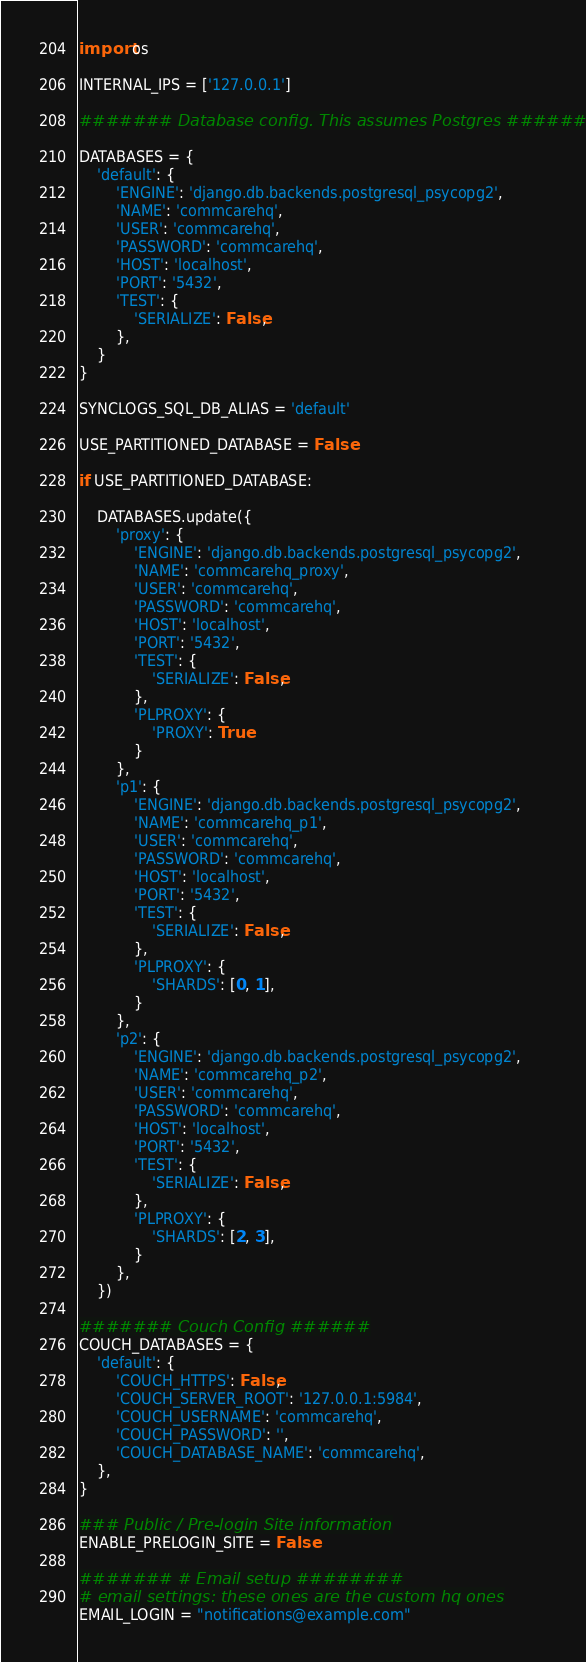Convert code to text. <code><loc_0><loc_0><loc_500><loc_500><_Python_>import os

INTERNAL_IPS = ['127.0.0.1']

####### Database config. This assumes Postgres #######

DATABASES = {
    'default': {
        'ENGINE': 'django.db.backends.postgresql_psycopg2',
        'NAME': 'commcarehq',
        'USER': 'commcarehq',
        'PASSWORD': 'commcarehq',
        'HOST': 'localhost',
        'PORT': '5432',
        'TEST': {
            'SERIALIZE': False,
        },
    }
}

SYNCLOGS_SQL_DB_ALIAS = 'default'

USE_PARTITIONED_DATABASE = False

if USE_PARTITIONED_DATABASE:

    DATABASES.update({
        'proxy': {
            'ENGINE': 'django.db.backends.postgresql_psycopg2',
            'NAME': 'commcarehq_proxy',
            'USER': 'commcarehq',
            'PASSWORD': 'commcarehq',
            'HOST': 'localhost',
            'PORT': '5432',
            'TEST': {
                'SERIALIZE': False,
            },
            'PLPROXY': {
                'PROXY': True
            }
        },
        'p1': {
            'ENGINE': 'django.db.backends.postgresql_psycopg2',
            'NAME': 'commcarehq_p1',
            'USER': 'commcarehq',
            'PASSWORD': 'commcarehq',
            'HOST': 'localhost',
            'PORT': '5432',
            'TEST': {
                'SERIALIZE': False,
            },
            'PLPROXY': {
                'SHARDS': [0, 1],
            }
        },
        'p2': {
            'ENGINE': 'django.db.backends.postgresql_psycopg2',
            'NAME': 'commcarehq_p2',
            'USER': 'commcarehq',
            'PASSWORD': 'commcarehq',
            'HOST': 'localhost',
            'PORT': '5432',
            'TEST': {
                'SERIALIZE': False,
            },
            'PLPROXY': {
                'SHARDS': [2, 3],
            }
        },
    })

####### Couch Config ######
COUCH_DATABASES = {
    'default': {
        'COUCH_HTTPS': False,
        'COUCH_SERVER_ROOT': '127.0.0.1:5984',
        'COUCH_USERNAME': 'commcarehq',
        'COUCH_PASSWORD': '',
        'COUCH_DATABASE_NAME': 'commcarehq',
    },
}

### Public / Pre-login Site information
ENABLE_PRELOGIN_SITE = False

####### # Email setup ########
# email settings: these ones are the custom hq ones
EMAIL_LOGIN = "notifications@example.com"</code> 